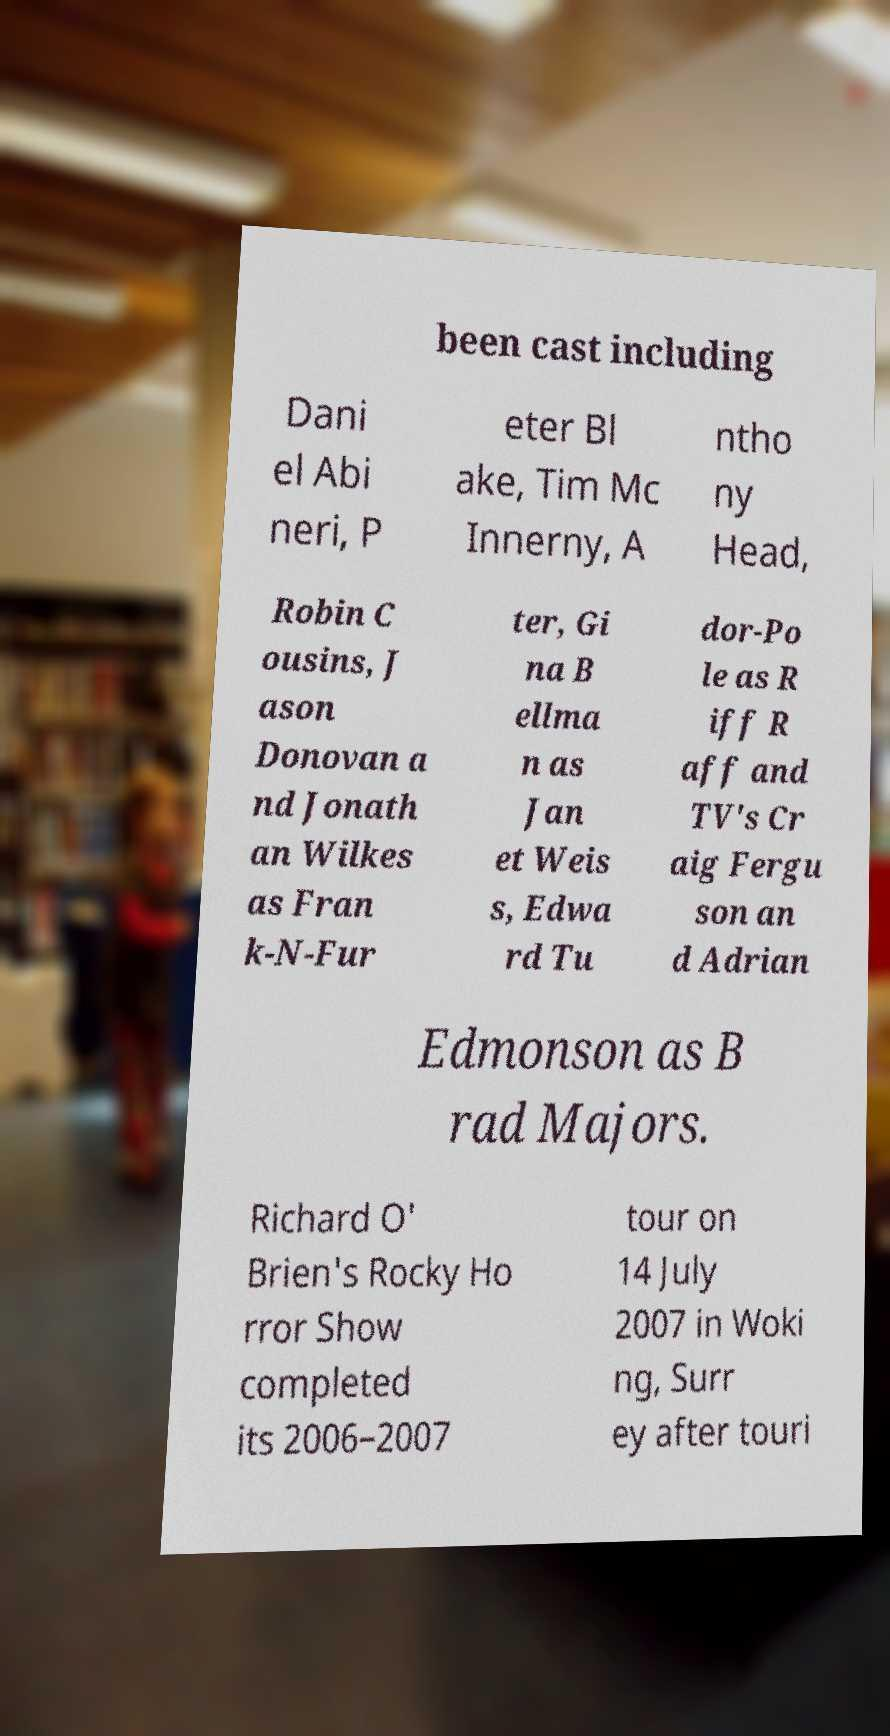Could you extract and type out the text from this image? been cast including Dani el Abi neri, P eter Bl ake, Tim Mc Innerny, A ntho ny Head, Robin C ousins, J ason Donovan a nd Jonath an Wilkes as Fran k-N-Fur ter, Gi na B ellma n as Jan et Weis s, Edwa rd Tu dor-Po le as R iff R aff and TV's Cr aig Fergu son an d Adrian Edmonson as B rad Majors. Richard O' Brien's Rocky Ho rror Show completed its 2006–2007 tour on 14 July 2007 in Woki ng, Surr ey after touri 